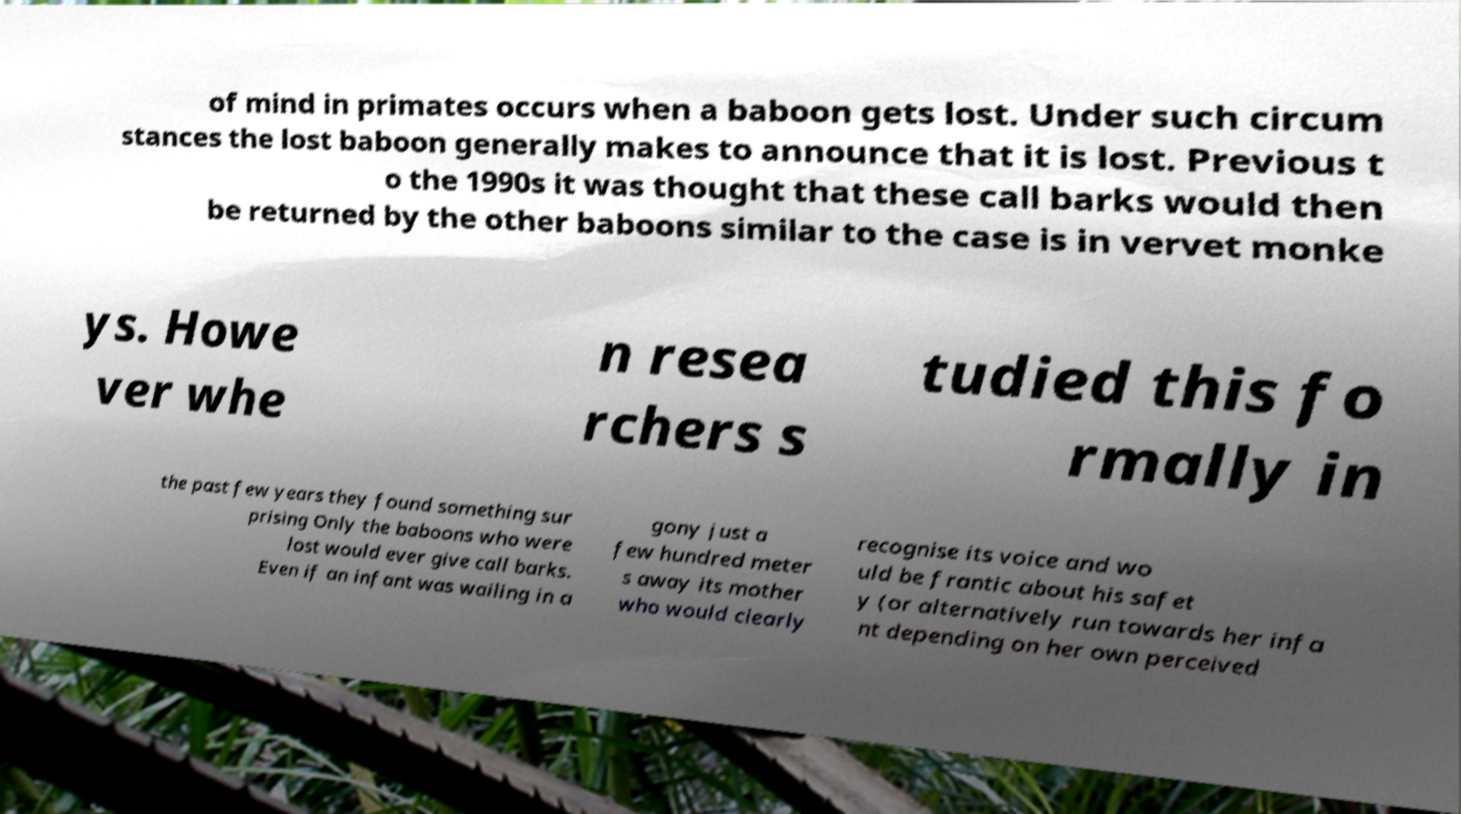Can you read and provide the text displayed in the image?This photo seems to have some interesting text. Can you extract and type it out for me? of mind in primates occurs when a baboon gets lost. Under such circum stances the lost baboon generally makes to announce that it is lost. Previous t o the 1990s it was thought that these call barks would then be returned by the other baboons similar to the case is in vervet monke ys. Howe ver whe n resea rchers s tudied this fo rmally in the past few years they found something sur prising Only the baboons who were lost would ever give call barks. Even if an infant was wailing in a gony just a few hundred meter s away its mother who would clearly recognise its voice and wo uld be frantic about his safet y (or alternatively run towards her infa nt depending on her own perceived 